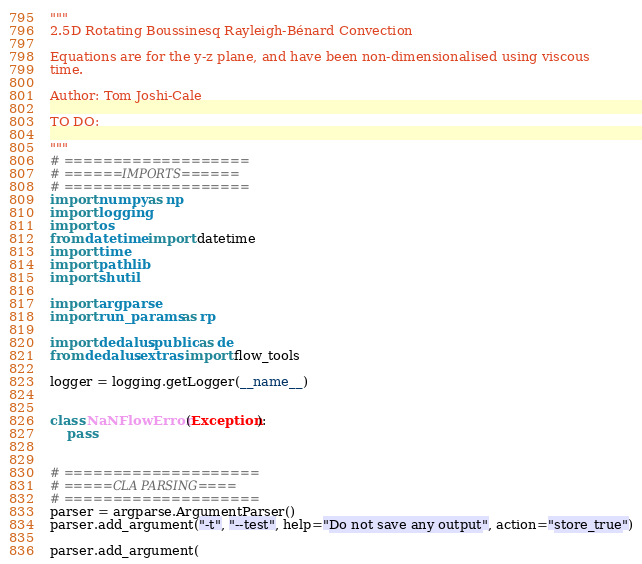Convert code to text. <code><loc_0><loc_0><loc_500><loc_500><_Python_>"""
2.5D Rotating Boussinesq Rayleigh-Bénard Convection

Equations are for the y-z plane, and have been non-dimensionalised using viscous
time.

Author: Tom Joshi-Cale

TO DO:

"""
# ===================
# ======IMPORTS======
# ===================
import numpy as np
import logging
import os
from datetime import datetime
import time
import pathlib
import shutil

import argparse
import run_params as rp

import dedalus.public as de
from dedalus.extras import flow_tools

logger = logging.getLogger(__name__)


class NaNFlowError(Exception):
    pass


# ====================
# =====CLA PARSING====
# ====================
parser = argparse.ArgumentParser()
parser.add_argument("-t", "--test", help="Do not save any output", action="store_true")

parser.add_argument(</code> 